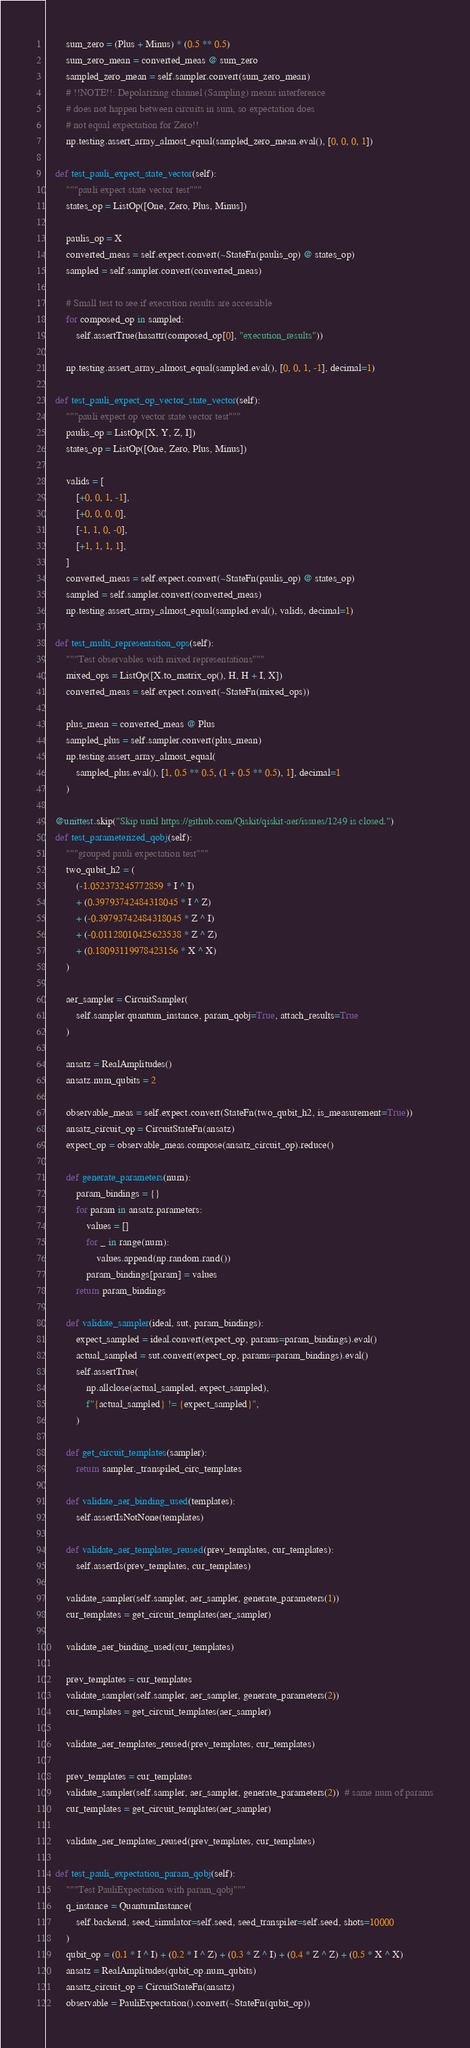Convert code to text. <code><loc_0><loc_0><loc_500><loc_500><_Python_>        sum_zero = (Plus + Minus) * (0.5 ** 0.5)
        sum_zero_mean = converted_meas @ sum_zero
        sampled_zero_mean = self.sampler.convert(sum_zero_mean)
        # !!NOTE!!: Depolarizing channel (Sampling) means interference
        # does not happen between circuits in sum, so expectation does
        # not equal expectation for Zero!!
        np.testing.assert_array_almost_equal(sampled_zero_mean.eval(), [0, 0, 0, 1])

    def test_pauli_expect_state_vector(self):
        """pauli expect state vector test"""
        states_op = ListOp([One, Zero, Plus, Minus])

        paulis_op = X
        converted_meas = self.expect.convert(~StateFn(paulis_op) @ states_op)
        sampled = self.sampler.convert(converted_meas)

        # Small test to see if execution results are accessible
        for composed_op in sampled:
            self.assertTrue(hasattr(composed_op[0], "execution_results"))

        np.testing.assert_array_almost_equal(sampled.eval(), [0, 0, 1, -1], decimal=1)

    def test_pauli_expect_op_vector_state_vector(self):
        """pauli expect op vector state vector test"""
        paulis_op = ListOp([X, Y, Z, I])
        states_op = ListOp([One, Zero, Plus, Minus])

        valids = [
            [+0, 0, 1, -1],
            [+0, 0, 0, 0],
            [-1, 1, 0, -0],
            [+1, 1, 1, 1],
        ]
        converted_meas = self.expect.convert(~StateFn(paulis_op) @ states_op)
        sampled = self.sampler.convert(converted_meas)
        np.testing.assert_array_almost_equal(sampled.eval(), valids, decimal=1)

    def test_multi_representation_ops(self):
        """Test observables with mixed representations"""
        mixed_ops = ListOp([X.to_matrix_op(), H, H + I, X])
        converted_meas = self.expect.convert(~StateFn(mixed_ops))

        plus_mean = converted_meas @ Plus
        sampled_plus = self.sampler.convert(plus_mean)
        np.testing.assert_array_almost_equal(
            sampled_plus.eval(), [1, 0.5 ** 0.5, (1 + 0.5 ** 0.5), 1], decimal=1
        )

    @unittest.skip("Skip until https://github.com/Qiskit/qiskit-aer/issues/1249 is closed.")
    def test_parameterized_qobj(self):
        """grouped pauli expectation test"""
        two_qubit_h2 = (
            (-1.052373245772859 * I ^ I)
            + (0.39793742484318045 * I ^ Z)
            + (-0.39793742484318045 * Z ^ I)
            + (-0.01128010425623538 * Z ^ Z)
            + (0.18093119978423156 * X ^ X)
        )

        aer_sampler = CircuitSampler(
            self.sampler.quantum_instance, param_qobj=True, attach_results=True
        )

        ansatz = RealAmplitudes()
        ansatz.num_qubits = 2

        observable_meas = self.expect.convert(StateFn(two_qubit_h2, is_measurement=True))
        ansatz_circuit_op = CircuitStateFn(ansatz)
        expect_op = observable_meas.compose(ansatz_circuit_op).reduce()

        def generate_parameters(num):
            param_bindings = {}
            for param in ansatz.parameters:
                values = []
                for _ in range(num):
                    values.append(np.random.rand())
                param_bindings[param] = values
            return param_bindings

        def validate_sampler(ideal, sut, param_bindings):
            expect_sampled = ideal.convert(expect_op, params=param_bindings).eval()
            actual_sampled = sut.convert(expect_op, params=param_bindings).eval()
            self.assertTrue(
                np.allclose(actual_sampled, expect_sampled),
                f"{actual_sampled} != {expect_sampled}",
            )

        def get_circuit_templates(sampler):
            return sampler._transpiled_circ_templates

        def validate_aer_binding_used(templates):
            self.assertIsNotNone(templates)

        def validate_aer_templates_reused(prev_templates, cur_templates):
            self.assertIs(prev_templates, cur_templates)

        validate_sampler(self.sampler, aer_sampler, generate_parameters(1))
        cur_templates = get_circuit_templates(aer_sampler)

        validate_aer_binding_used(cur_templates)

        prev_templates = cur_templates
        validate_sampler(self.sampler, aer_sampler, generate_parameters(2))
        cur_templates = get_circuit_templates(aer_sampler)

        validate_aer_templates_reused(prev_templates, cur_templates)

        prev_templates = cur_templates
        validate_sampler(self.sampler, aer_sampler, generate_parameters(2))  # same num of params
        cur_templates = get_circuit_templates(aer_sampler)

        validate_aer_templates_reused(prev_templates, cur_templates)

    def test_pauli_expectation_param_qobj(self):
        """Test PauliExpectation with param_qobj"""
        q_instance = QuantumInstance(
            self.backend, seed_simulator=self.seed, seed_transpiler=self.seed, shots=10000
        )
        qubit_op = (0.1 * I ^ I) + (0.2 * I ^ Z) + (0.3 * Z ^ I) + (0.4 * Z ^ Z) + (0.5 * X ^ X)
        ansatz = RealAmplitudes(qubit_op.num_qubits)
        ansatz_circuit_op = CircuitStateFn(ansatz)
        observable = PauliExpectation().convert(~StateFn(qubit_op))</code> 